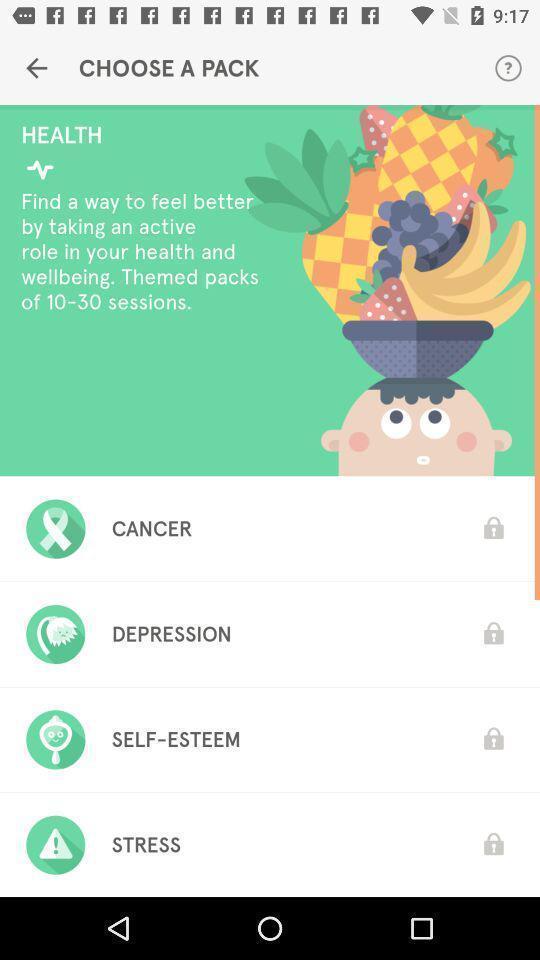Describe the content in this image. Page for choosing a pack of a health app. 